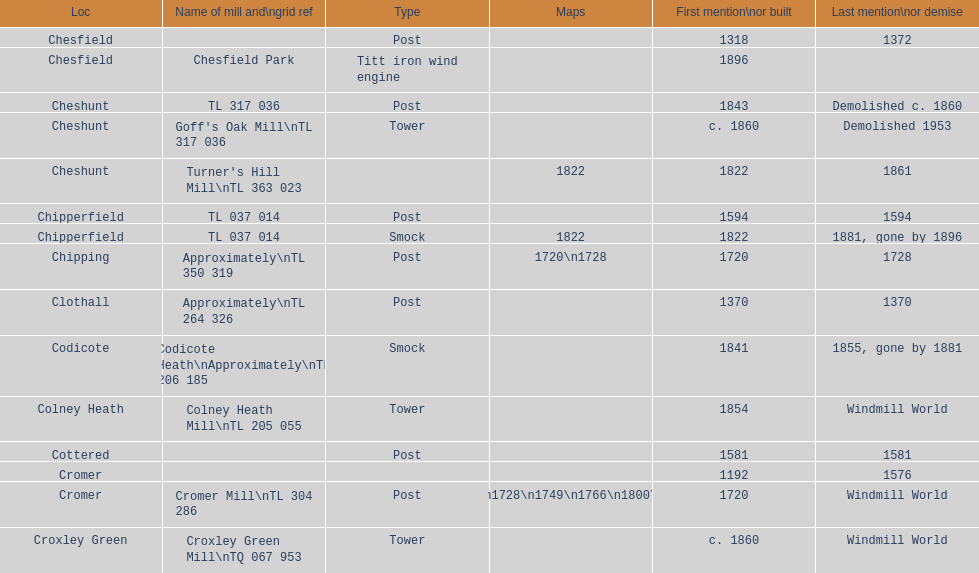What is the number of mills built or first referred to after the year 1800? 8. 